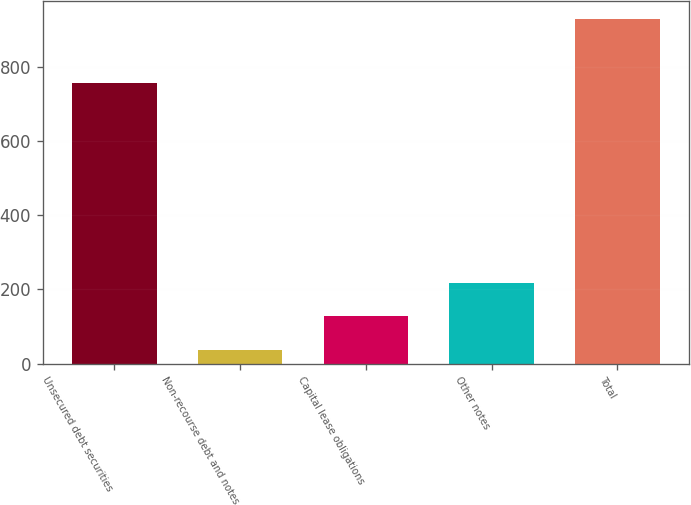Convert chart. <chart><loc_0><loc_0><loc_500><loc_500><bar_chart><fcel>Unsecured debt securities<fcel>Non-recourse debt and notes<fcel>Capital lease obligations<fcel>Other notes<fcel>Total<nl><fcel>755<fcel>38<fcel>127.1<fcel>216.2<fcel>929<nl></chart> 